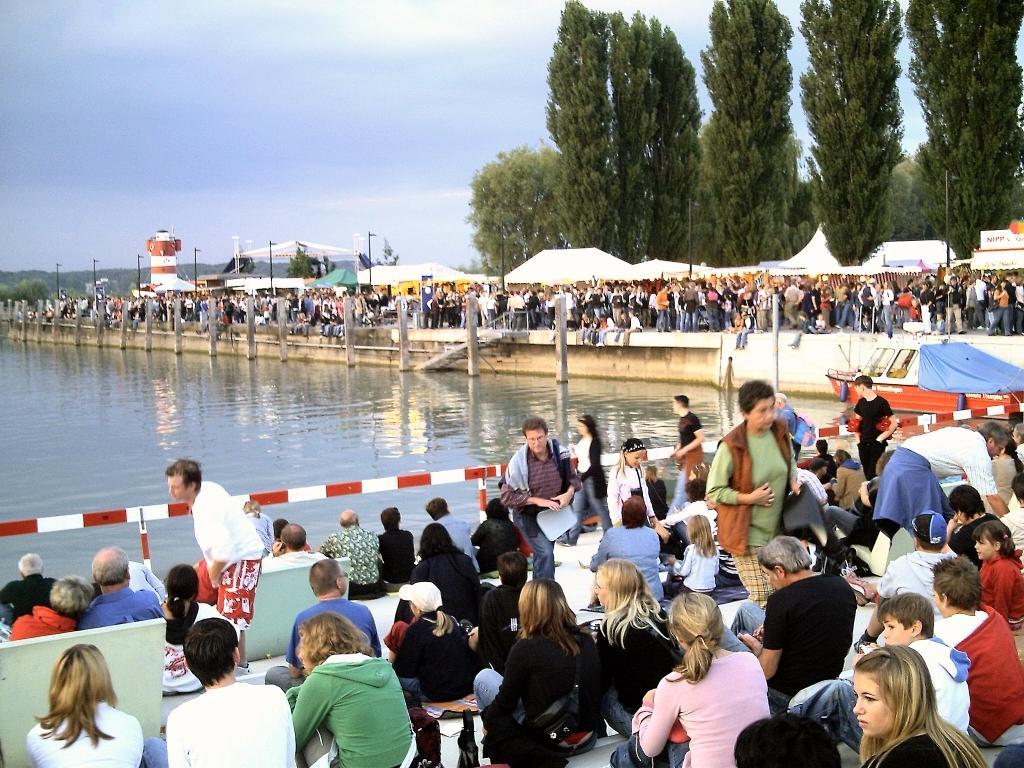Can you describe this image briefly? In this picture I can see many persons who are standing near to the tent. At the bottom I can see another group of persons who are sitting on the floor and some persons are standing. In front of them I can see the fencing and lake. On the right there is an orange color boat near to the fencing. In the background I can see the trees, mountains, street lights and other objects. At the top I can see the sky and clouds. 